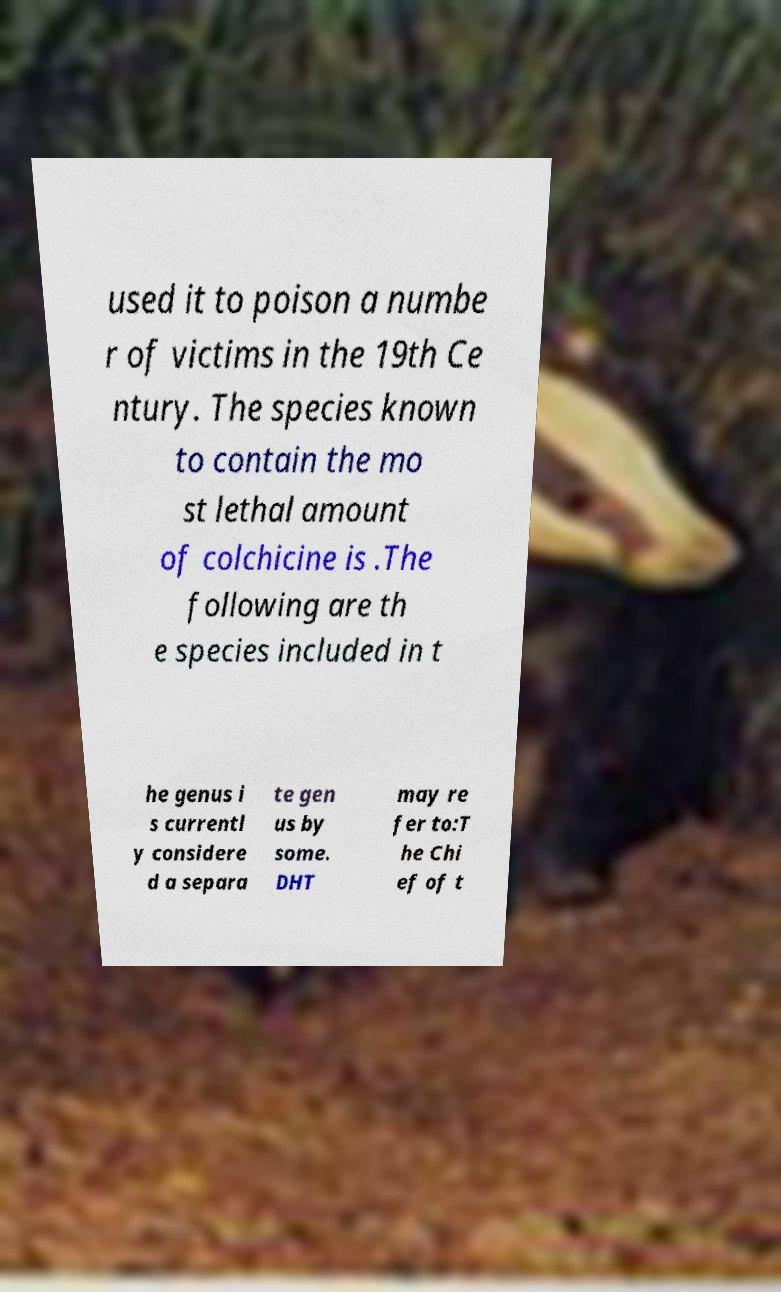What messages or text are displayed in this image? I need them in a readable, typed format. used it to poison a numbe r of victims in the 19th Ce ntury. The species known to contain the mo st lethal amount of colchicine is .The following are th e species included in t he genus i s currentl y considere d a separa te gen us by some. DHT may re fer to:T he Chi ef of t 